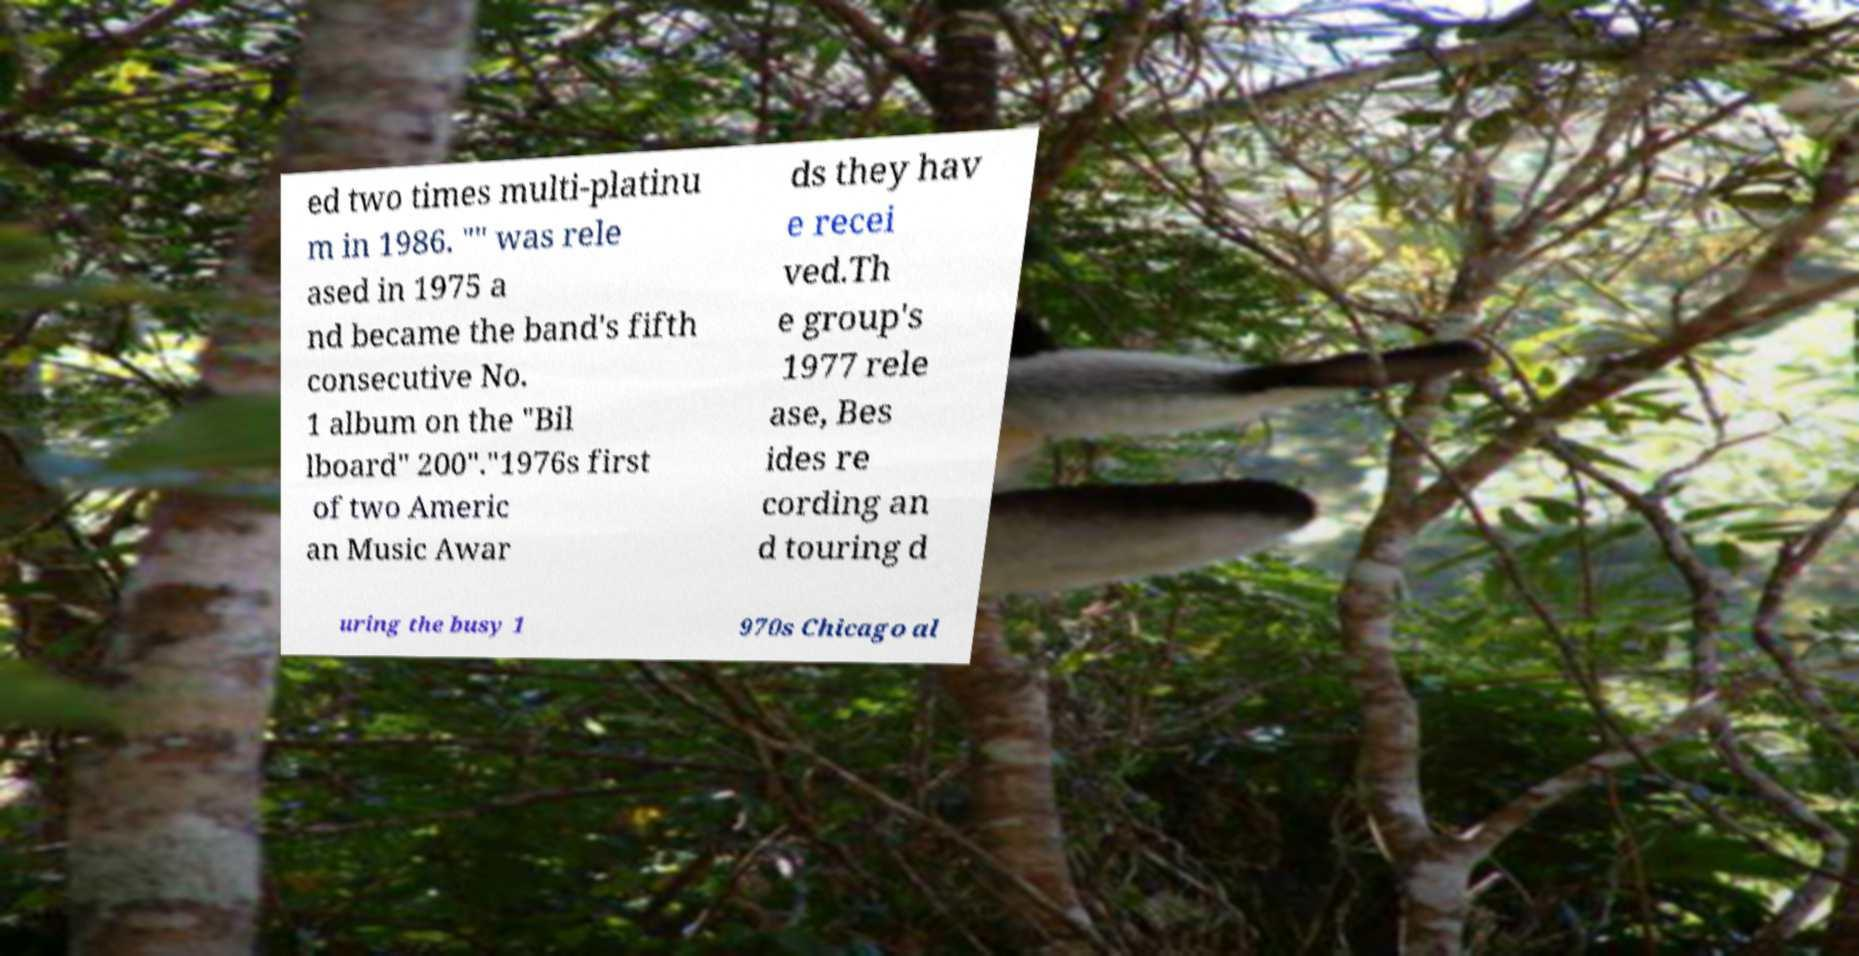Please read and relay the text visible in this image. What does it say? ed two times multi-platinu m in 1986. "" was rele ased in 1975 a nd became the band's fifth consecutive No. 1 album on the "Bil lboard" 200"."1976s first of two Americ an Music Awar ds they hav e recei ved.Th e group's 1977 rele ase, Bes ides re cording an d touring d uring the busy 1 970s Chicago al 